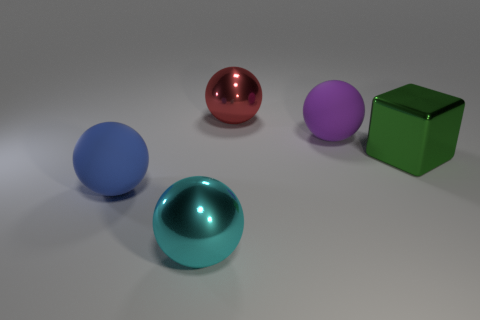Is the number of big cyan metal balls in front of the big green object less than the number of balls that are in front of the red sphere?
Keep it short and to the point. Yes. How big is the shiny sphere that is behind the large cube?
Your answer should be very brief. Large. Are there any green things made of the same material as the red ball?
Provide a succinct answer. Yes. Is the large purple thing made of the same material as the large blue thing?
Your answer should be very brief. Yes. There is a cube that is the same size as the purple ball; what is its color?
Provide a succinct answer. Green. What number of other objects are the same shape as the cyan thing?
Make the answer very short. 3. There is a green cube; does it have the same size as the matte object left of the large red shiny ball?
Provide a succinct answer. Yes. What number of things are either cyan metal balls or green shiny objects?
Provide a short and direct response. 2. What number of other objects are there of the same size as the red ball?
Make the answer very short. 4. What number of balls are cyan rubber things or large matte things?
Keep it short and to the point. 2. 